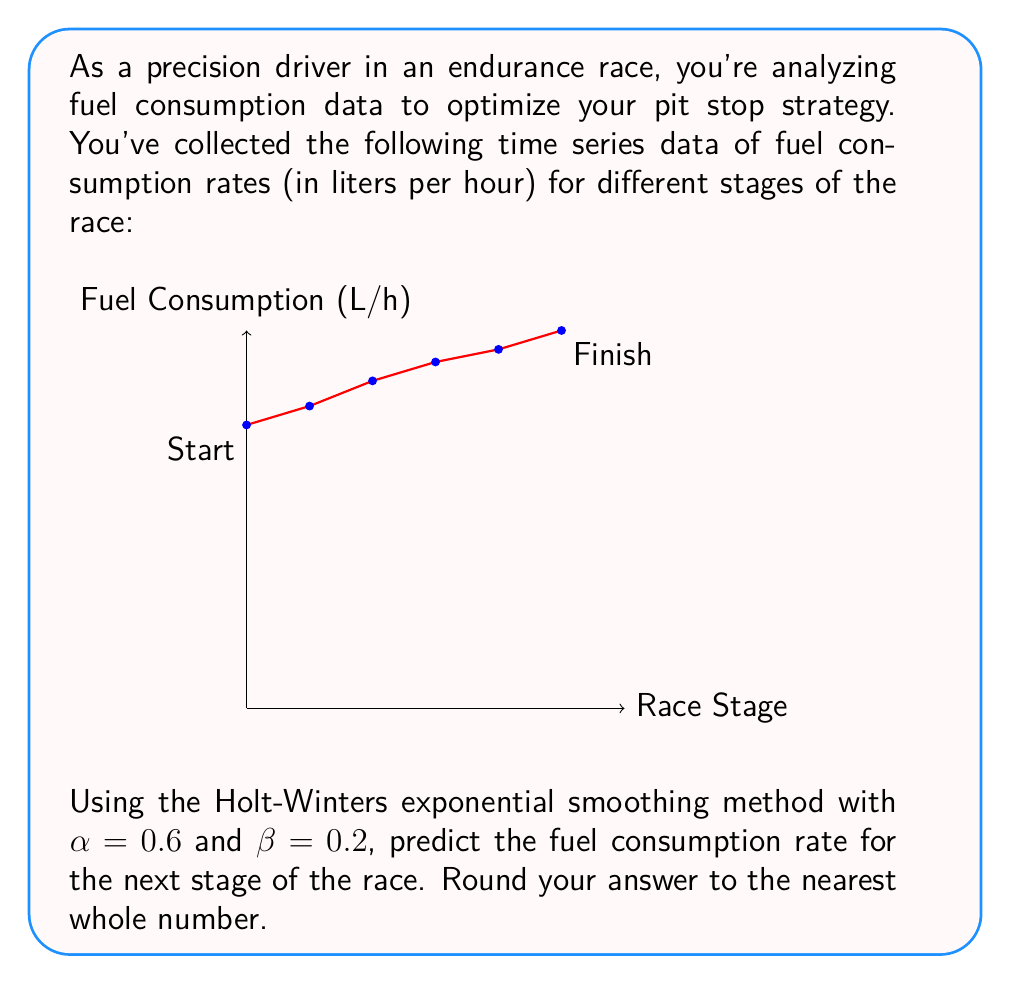Show me your answer to this math problem. To solve this problem using the Holt-Winters exponential smoothing method, we'll follow these steps:

1) The Holt-Winters method uses two equations:
   Level: $L_t = \alpha Y_t + (1-\alpha)(L_{t-1} + T_{t-1})$
   Trend: $T_t = \beta(L_t - L_{t-1}) + (1-\beta)T_{t-1}$

   Where $Y_t$ is the observed value, $L_t$ is the level, and $T_t$ is the trend.

2) Initialize $L_0$ and $T_0$:
   $L_0 = Y_0 = 45$
   $T_0 = Y_1 - Y_0 = 48 - 45 = 3$

3) Calculate for each time step:

   For t=1:
   $L_1 = 0.6(48) + 0.4(45 + 3) = 28.8 + 19.2 = 48$
   $T_1 = 0.2(48 - 45) + 0.8(3) = 0.6 + 2.4 = 3$

   For t=2:
   $L_2 = 0.6(52) + 0.4(48 + 3) = 31.2 + 20.4 = 51.6$
   $T_2 = 0.2(51.6 - 48) + 0.8(3) = 0.72 + 2.4 = 3.12$

   For t=3:
   $L_3 = 0.6(55) + 0.4(51.6 + 3.12) = 33 + 21.888 = 54.888$
   $T_3 = 0.2(54.888 - 51.6) + 0.8(3.12) = 0.6576 + 2.496 = 3.1536$

   For t=4:
   $L_4 = 0.6(57) + 0.4(54.888 + 3.1536) = 34.2 + 23.2166 = 57.4166$
   $T_4 = 0.2(57.4166 - 54.888) + 0.8(3.1536) = 0.50572 + 2.52288 = 3.0286$

   For t=5:
   $L_5 = 0.6(60) + 0.4(57.4166 + 3.0286) = 36 + 24.1781 = 60.1781$
   $T_5 = 0.2(60.1781 - 57.4166) + 0.8(3.0286) = 0.55230 + 2.42288 = 2.97518$

4) Predict the next value:
   $Y_6 = L_5 + T_5 = 60.1781 + 2.97518 = 63.15328$

5) Rounding to the nearest whole number: 63
Answer: 63 L/h 